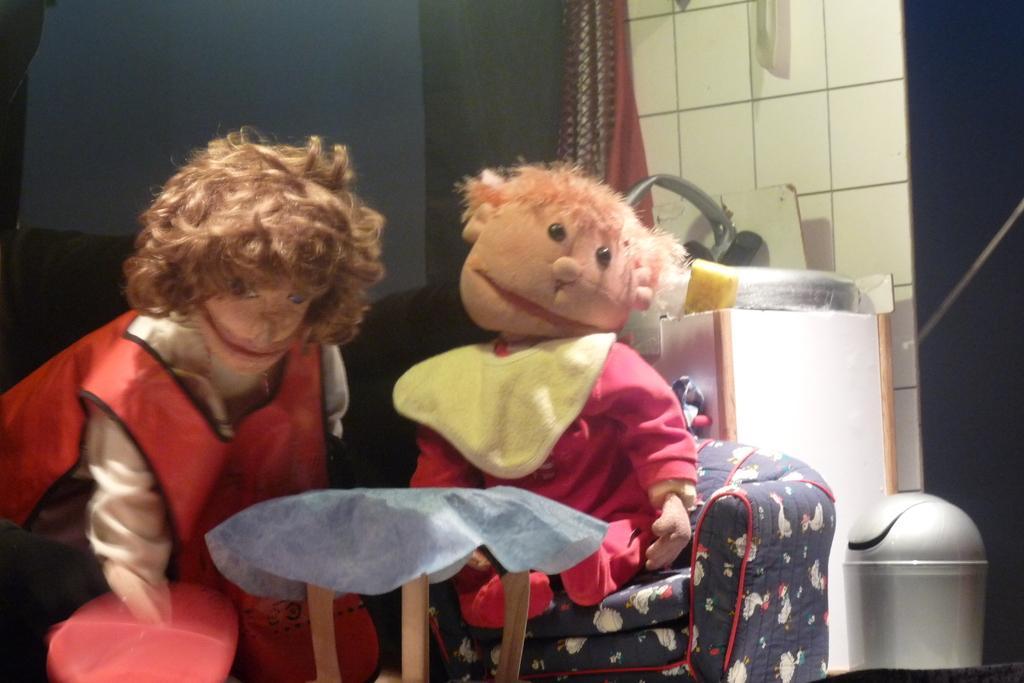How would you summarize this image in a sentence or two? In the image we can see there are two toys. Here we can see the couch, garbage bin, wall and the curtains. Here we can see some objects. 